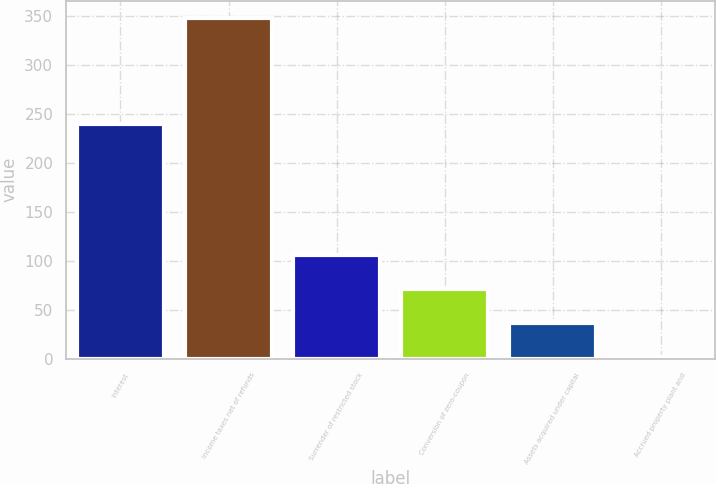Convert chart to OTSL. <chart><loc_0><loc_0><loc_500><loc_500><bar_chart><fcel>Interest<fcel>Income taxes net of refunds<fcel>Surrender of restricted stock<fcel>Conversion of zero-coupon<fcel>Assets acquired under capital<fcel>Accrued property plant and<nl><fcel>239.1<fcel>348<fcel>105.52<fcel>70.88<fcel>36.24<fcel>1.6<nl></chart> 